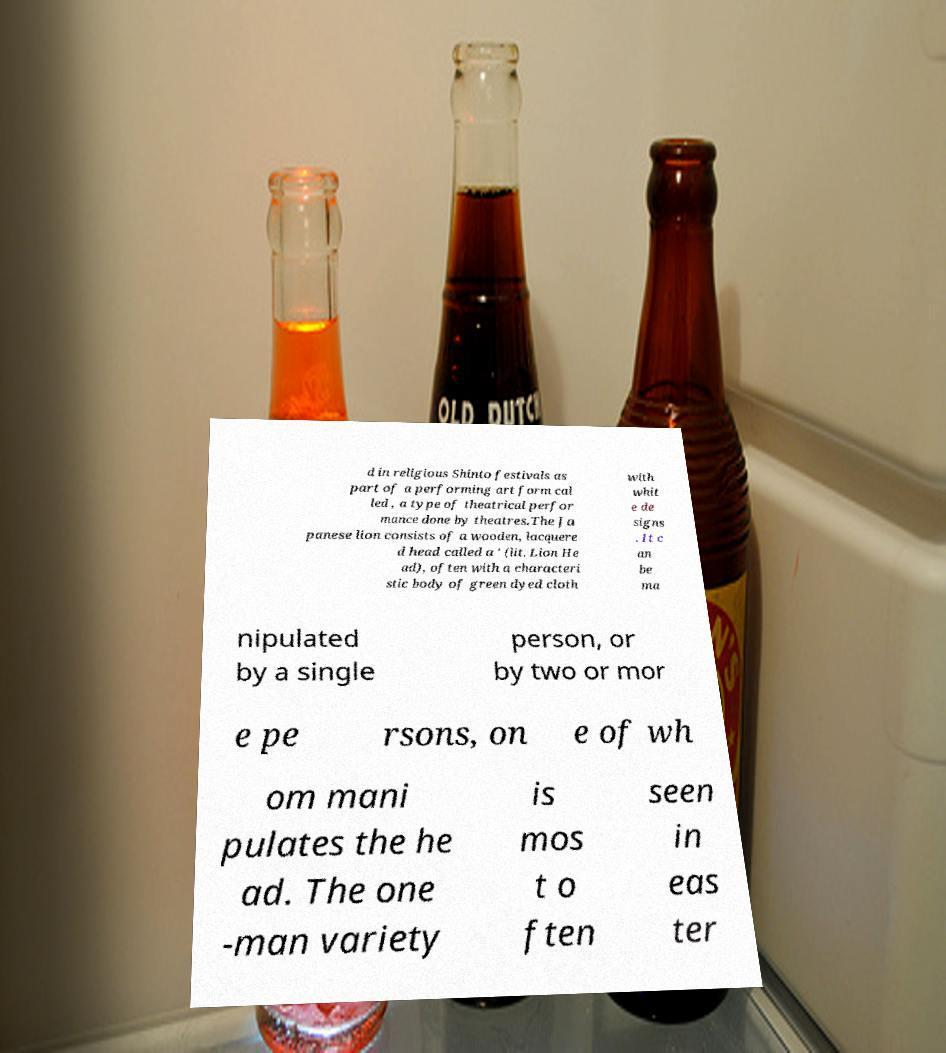Please read and relay the text visible in this image. What does it say? d in religious Shinto festivals as part of a performing art form cal led , a type of theatrical perfor mance done by theatres.The Ja panese lion consists of a wooden, lacquere d head called a ' (lit. Lion He ad), often with a characteri stic body of green dyed cloth with whit e de signs . It c an be ma nipulated by a single person, or by two or mor e pe rsons, on e of wh om mani pulates the he ad. The one -man variety is mos t o ften seen in eas ter 